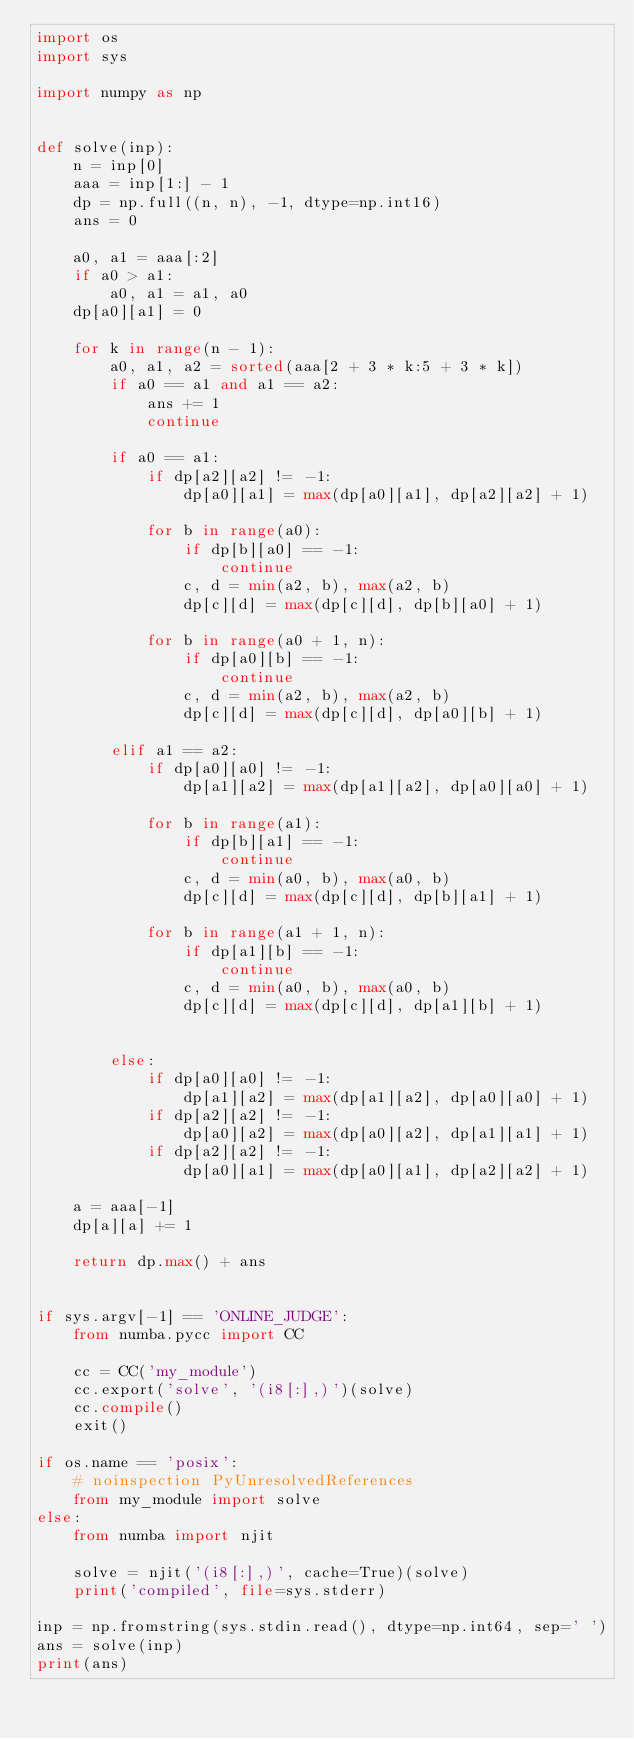<code> <loc_0><loc_0><loc_500><loc_500><_Python_>import os
import sys

import numpy as np


def solve(inp):
    n = inp[0]
    aaa = inp[1:] - 1
    dp = np.full((n, n), -1, dtype=np.int16)
    ans = 0

    a0, a1 = aaa[:2]
    if a0 > a1:
        a0, a1 = a1, a0
    dp[a0][a1] = 0

    for k in range(n - 1):
        a0, a1, a2 = sorted(aaa[2 + 3 * k:5 + 3 * k])
        if a0 == a1 and a1 == a2:
            ans += 1
            continue

        if a0 == a1:
            if dp[a2][a2] != -1:
                dp[a0][a1] = max(dp[a0][a1], dp[a2][a2] + 1)

            for b in range(a0):
                if dp[b][a0] == -1:
                    continue
                c, d = min(a2, b), max(a2, b)
                dp[c][d] = max(dp[c][d], dp[b][a0] + 1)

            for b in range(a0 + 1, n):
                if dp[a0][b] == -1:
                    continue
                c, d = min(a2, b), max(a2, b)
                dp[c][d] = max(dp[c][d], dp[a0][b] + 1)

        elif a1 == a2:
            if dp[a0][a0] != -1:
                dp[a1][a2] = max(dp[a1][a2], dp[a0][a0] + 1)
               
            for b in range(a1):
                if dp[b][a1] == -1:
                    continue
                c, d = min(a0, b), max(a0, b)
                dp[c][d] = max(dp[c][d], dp[b][a1] + 1)

            for b in range(a1 + 1, n):
                if dp[a1][b] == -1:
                    continue
                c, d = min(a0, b), max(a0, b)
                dp[c][d] = max(dp[c][d], dp[a1][b] + 1)


        else:
            if dp[a0][a0] != -1:
                dp[a1][a2] = max(dp[a1][a2], dp[a0][a0] + 1)
            if dp[a2][a2] != -1:
                dp[a0][a2] = max(dp[a0][a2], dp[a1][a1] + 1)
            if dp[a2][a2] != -1:
                dp[a0][a1] = max(dp[a0][a1], dp[a2][a2] + 1)

    a = aaa[-1]
    dp[a][a] += 1

    return dp.max() + ans


if sys.argv[-1] == 'ONLINE_JUDGE':
    from numba.pycc import CC

    cc = CC('my_module')
    cc.export('solve', '(i8[:],)')(solve)
    cc.compile()
    exit()

if os.name == 'posix':
    # noinspection PyUnresolvedReferences
    from my_module import solve
else:
    from numba import njit

    solve = njit('(i8[:],)', cache=True)(solve)
    print('compiled', file=sys.stderr)

inp = np.fromstring(sys.stdin.read(), dtype=np.int64, sep=' ')
ans = solve(inp)
print(ans)
</code> 